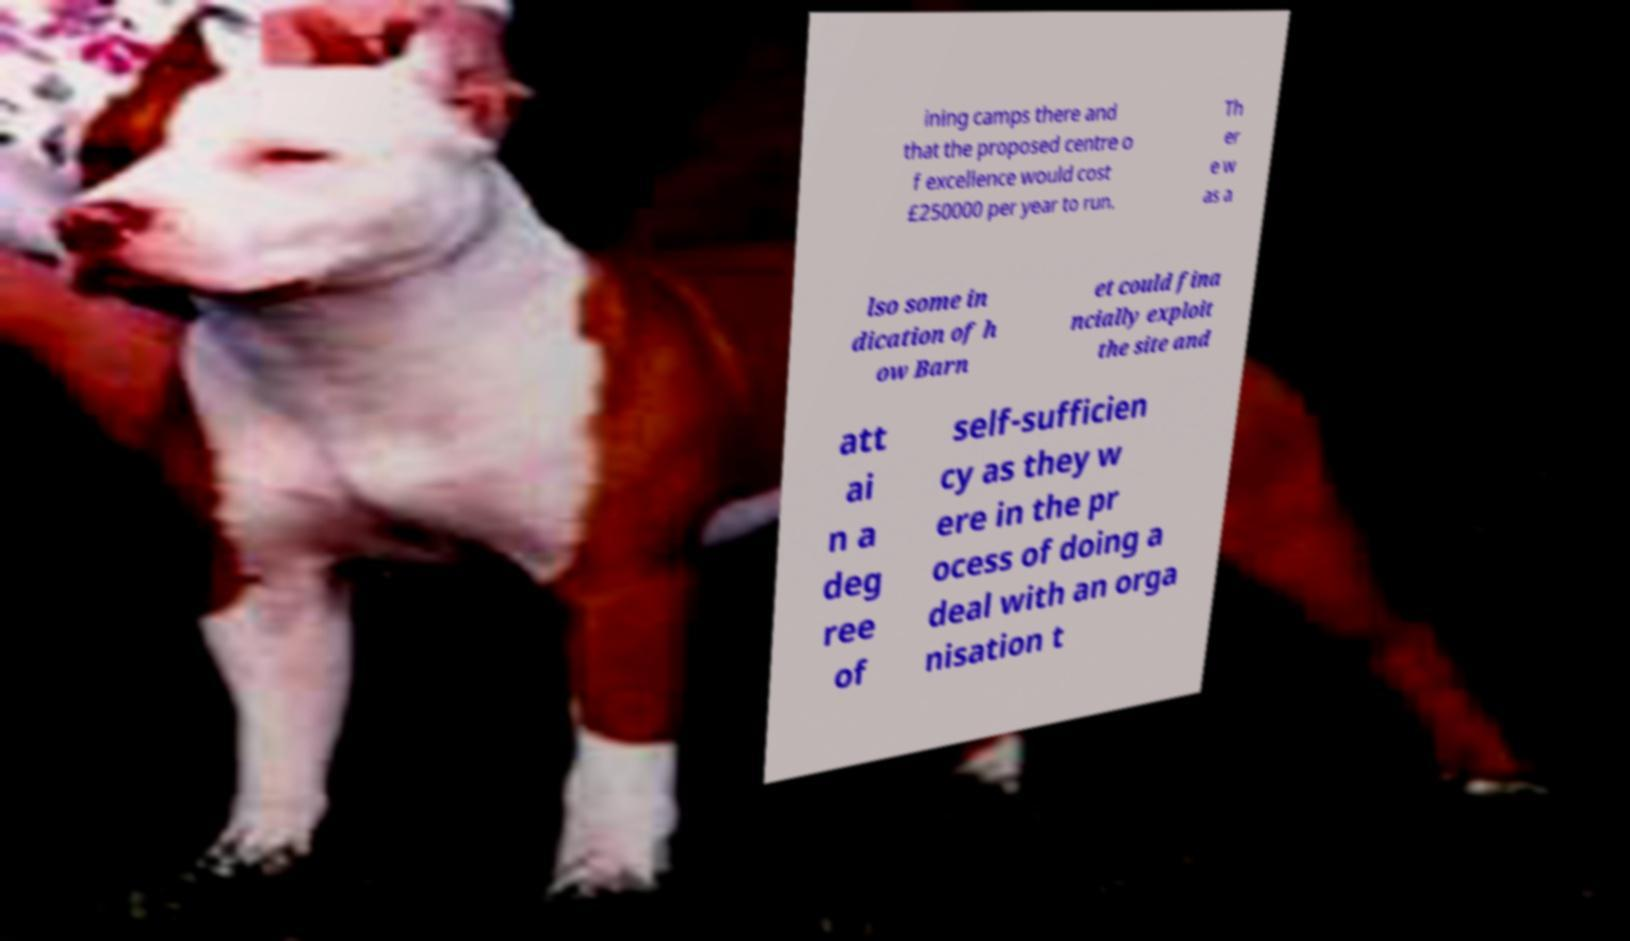Can you read and provide the text displayed in the image?This photo seems to have some interesting text. Can you extract and type it out for me? ining camps there and that the proposed centre o f excellence would cost £250000 per year to run. Th er e w as a lso some in dication of h ow Barn et could fina ncially exploit the site and att ai n a deg ree of self-sufficien cy as they w ere in the pr ocess of doing a deal with an orga nisation t 